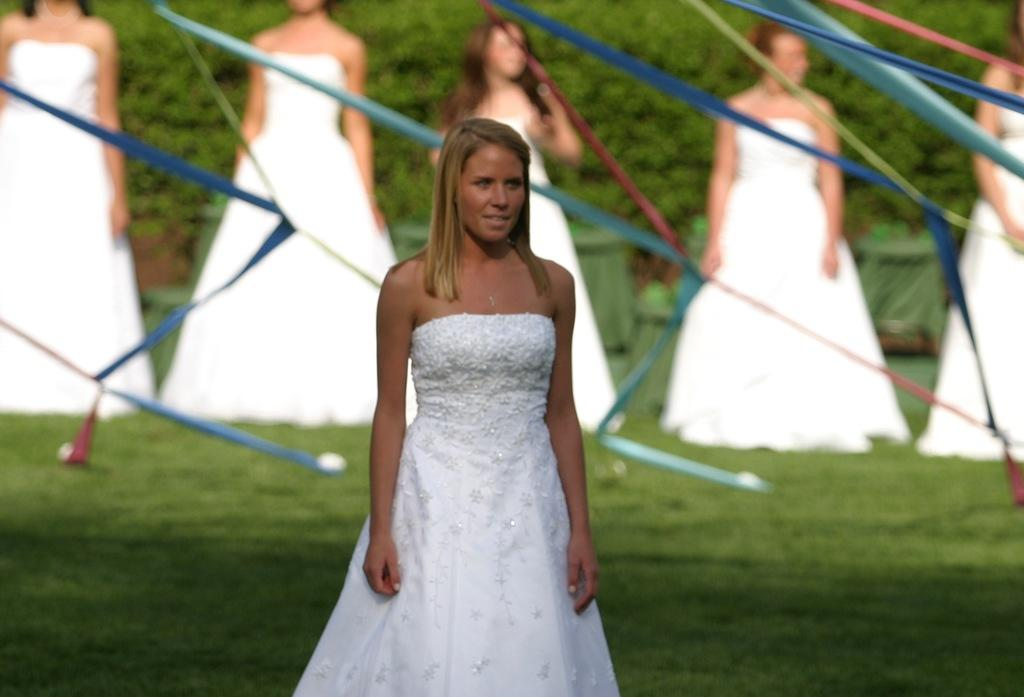How many women are in the foreground of the image? There are six women standing in the foreground of the image. What is the surface the women are standing on? The women are standing on grass. What additional items can be seen in the image? Ribbons are visible in the image. What can be seen in the background of the image? There are trees in the background of the image. What type of location might the image have been taken in? The image might have been taken in a park. Where is the sofa located in the image? There is no sofa present in the image. What type of animal can be seen interacting with the women in the image? There is no animal present in the image; only the six women, grass, ribbons, and trees are visible. 